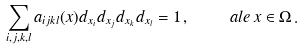Convert formula to latex. <formula><loc_0><loc_0><loc_500><loc_500>\sum _ { i , j , k , l } a _ { i j k l } ( x ) d _ { x _ { i } } d _ { x _ { j } } d _ { x _ { k } } d _ { x _ { l } } = 1 \, , \quad \ a l e \, x \in \Omega \, .</formula> 